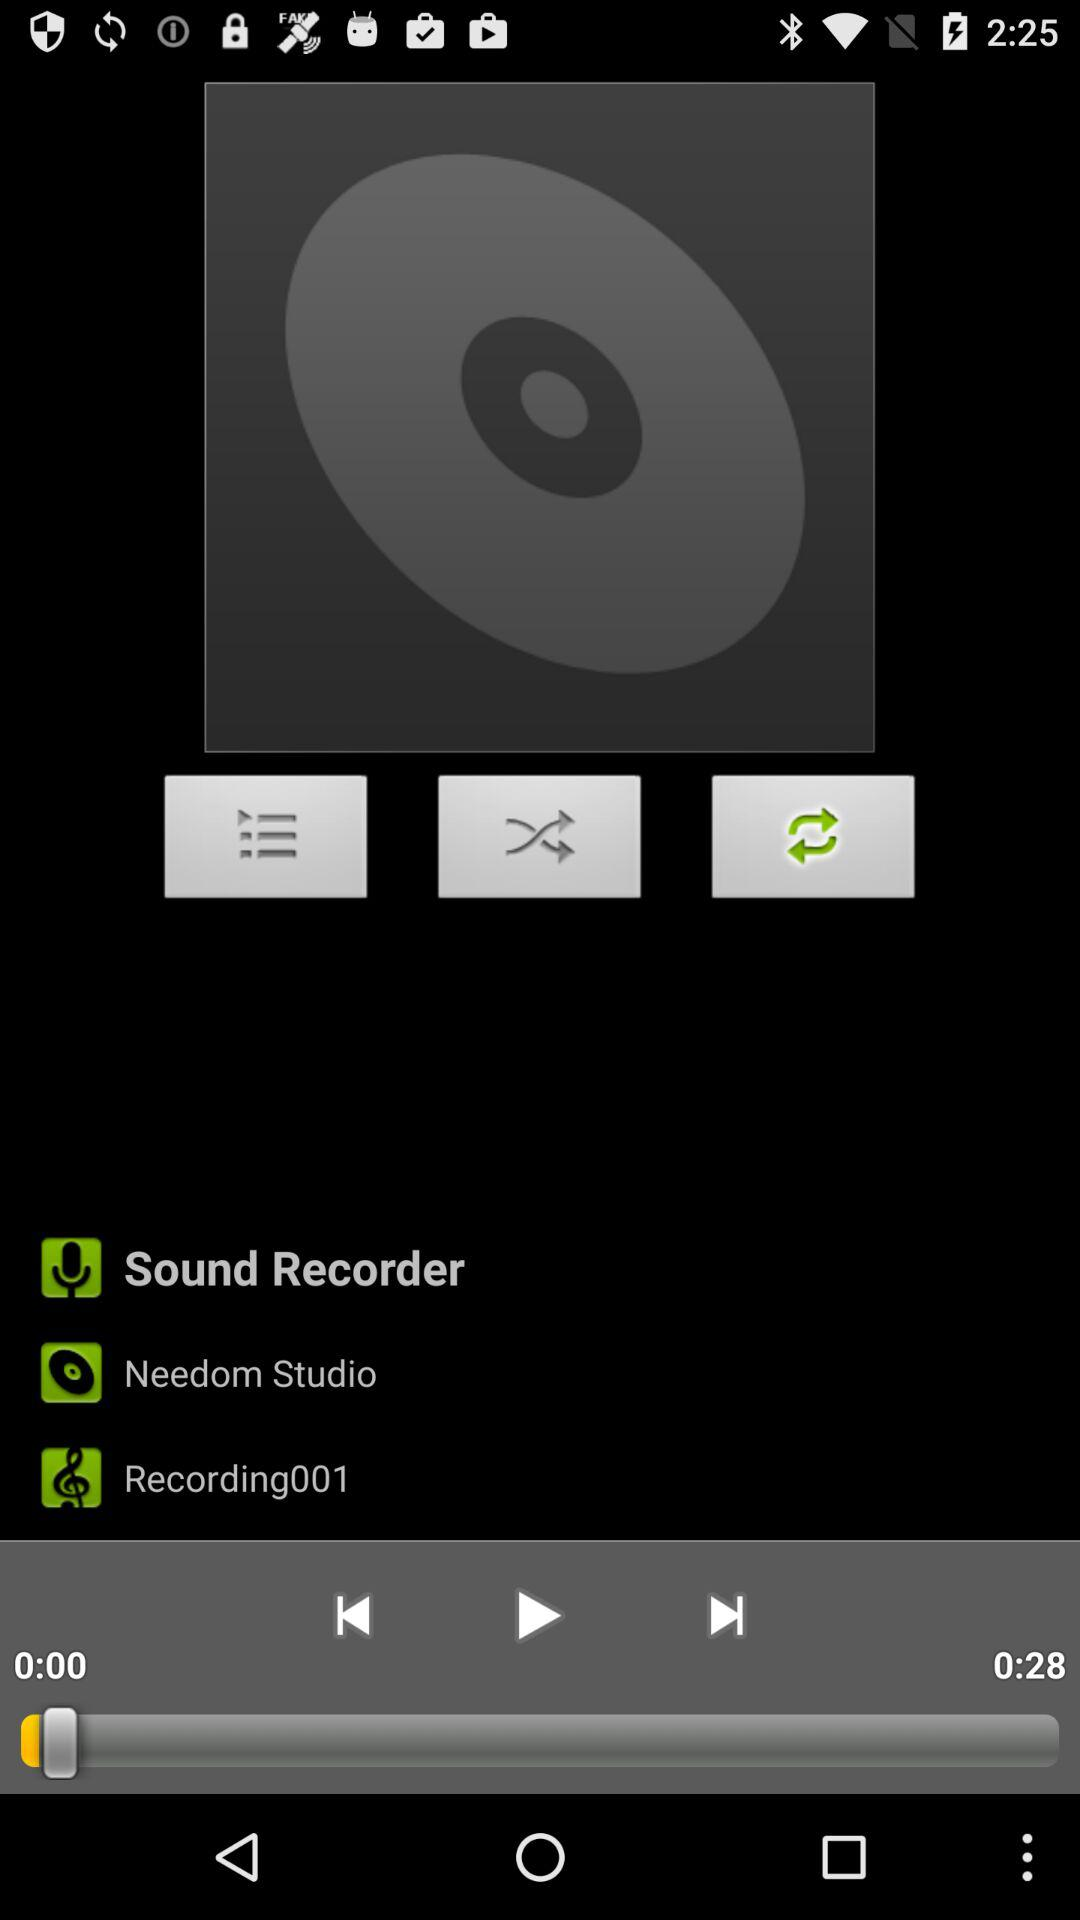What is the duration of the audio? The duration of the audio is 28 seconds. 